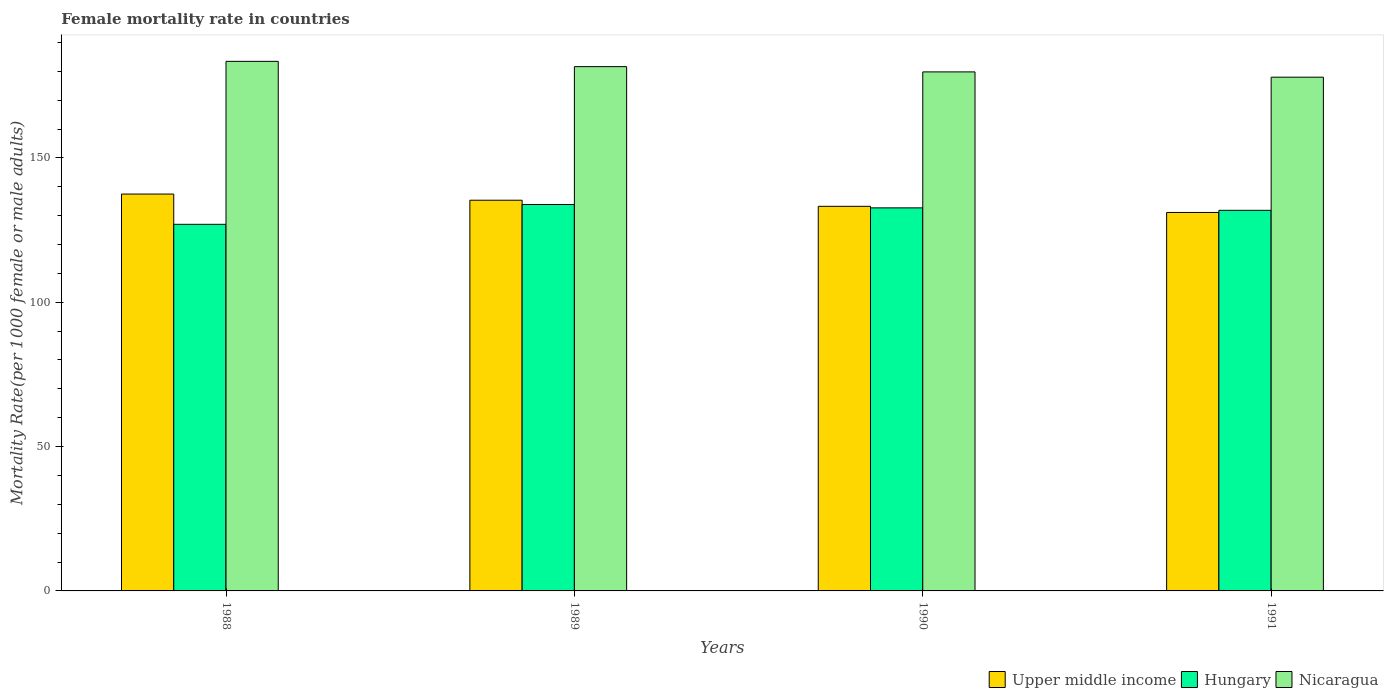How many different coloured bars are there?
Give a very brief answer. 3. How many groups of bars are there?
Offer a very short reply. 4. How many bars are there on the 1st tick from the right?
Ensure brevity in your answer.  3. What is the female mortality rate in Upper middle income in 1988?
Your response must be concise. 137.48. Across all years, what is the maximum female mortality rate in Upper middle income?
Your answer should be very brief. 137.48. Across all years, what is the minimum female mortality rate in Upper middle income?
Ensure brevity in your answer.  131.1. In which year was the female mortality rate in Upper middle income minimum?
Offer a terse response. 1991. What is the total female mortality rate in Upper middle income in the graph?
Your answer should be very brief. 537.16. What is the difference between the female mortality rate in Upper middle income in 1989 and that in 1991?
Offer a very short reply. 4.24. What is the difference between the female mortality rate in Hungary in 1989 and the female mortality rate in Nicaragua in 1991?
Keep it short and to the point. -44.12. What is the average female mortality rate in Upper middle income per year?
Provide a short and direct response. 134.29. In the year 1988, what is the difference between the female mortality rate in Nicaragua and female mortality rate in Hungary?
Offer a very short reply. 56.45. In how many years, is the female mortality rate in Nicaragua greater than 110?
Provide a short and direct response. 4. What is the ratio of the female mortality rate in Upper middle income in 1990 to that in 1991?
Offer a terse response. 1.02. Is the female mortality rate in Hungary in 1989 less than that in 1991?
Provide a succinct answer. No. What is the difference between the highest and the second highest female mortality rate in Hungary?
Make the answer very short. 1.16. What is the difference between the highest and the lowest female mortality rate in Hungary?
Your answer should be compact. 6.86. In how many years, is the female mortality rate in Hungary greater than the average female mortality rate in Hungary taken over all years?
Keep it short and to the point. 3. Is the sum of the female mortality rate in Upper middle income in 1988 and 1990 greater than the maximum female mortality rate in Hungary across all years?
Make the answer very short. Yes. What does the 2nd bar from the left in 1990 represents?
Keep it short and to the point. Hungary. What does the 2nd bar from the right in 1989 represents?
Make the answer very short. Hungary. Is it the case that in every year, the sum of the female mortality rate in Hungary and female mortality rate in Upper middle income is greater than the female mortality rate in Nicaragua?
Provide a short and direct response. Yes. How many years are there in the graph?
Your answer should be compact. 4. What is the difference between two consecutive major ticks on the Y-axis?
Make the answer very short. 50. Are the values on the major ticks of Y-axis written in scientific E-notation?
Keep it short and to the point. No. Does the graph contain grids?
Your answer should be compact. No. Where does the legend appear in the graph?
Ensure brevity in your answer.  Bottom right. How many legend labels are there?
Ensure brevity in your answer.  3. What is the title of the graph?
Your response must be concise. Female mortality rate in countries. Does "Albania" appear as one of the legend labels in the graph?
Offer a very short reply. No. What is the label or title of the Y-axis?
Your answer should be compact. Mortality Rate(per 1000 female or male adults). What is the Mortality Rate(per 1000 female or male adults) of Upper middle income in 1988?
Your answer should be very brief. 137.48. What is the Mortality Rate(per 1000 female or male adults) in Hungary in 1988?
Your answer should be compact. 127. What is the Mortality Rate(per 1000 female or male adults) of Nicaragua in 1988?
Ensure brevity in your answer.  183.45. What is the Mortality Rate(per 1000 female or male adults) of Upper middle income in 1989?
Your answer should be compact. 135.34. What is the Mortality Rate(per 1000 female or male adults) of Hungary in 1989?
Make the answer very short. 133.85. What is the Mortality Rate(per 1000 female or male adults) in Nicaragua in 1989?
Offer a terse response. 181.62. What is the Mortality Rate(per 1000 female or male adults) in Upper middle income in 1990?
Offer a terse response. 133.23. What is the Mortality Rate(per 1000 female or male adults) of Hungary in 1990?
Offer a terse response. 132.69. What is the Mortality Rate(per 1000 female or male adults) of Nicaragua in 1990?
Provide a short and direct response. 179.8. What is the Mortality Rate(per 1000 female or male adults) in Upper middle income in 1991?
Your response must be concise. 131.1. What is the Mortality Rate(per 1000 female or male adults) of Hungary in 1991?
Provide a succinct answer. 131.85. What is the Mortality Rate(per 1000 female or male adults) in Nicaragua in 1991?
Keep it short and to the point. 177.97. Across all years, what is the maximum Mortality Rate(per 1000 female or male adults) in Upper middle income?
Offer a terse response. 137.48. Across all years, what is the maximum Mortality Rate(per 1000 female or male adults) of Hungary?
Give a very brief answer. 133.85. Across all years, what is the maximum Mortality Rate(per 1000 female or male adults) of Nicaragua?
Offer a terse response. 183.45. Across all years, what is the minimum Mortality Rate(per 1000 female or male adults) of Upper middle income?
Your response must be concise. 131.1. Across all years, what is the minimum Mortality Rate(per 1000 female or male adults) in Hungary?
Ensure brevity in your answer.  127. Across all years, what is the minimum Mortality Rate(per 1000 female or male adults) in Nicaragua?
Keep it short and to the point. 177.97. What is the total Mortality Rate(per 1000 female or male adults) of Upper middle income in the graph?
Offer a terse response. 537.16. What is the total Mortality Rate(per 1000 female or male adults) in Hungary in the graph?
Your answer should be very brief. 525.39. What is the total Mortality Rate(per 1000 female or male adults) of Nicaragua in the graph?
Keep it short and to the point. 722.84. What is the difference between the Mortality Rate(per 1000 female or male adults) in Upper middle income in 1988 and that in 1989?
Ensure brevity in your answer.  2.14. What is the difference between the Mortality Rate(per 1000 female or male adults) in Hungary in 1988 and that in 1989?
Provide a short and direct response. -6.86. What is the difference between the Mortality Rate(per 1000 female or male adults) in Nicaragua in 1988 and that in 1989?
Your response must be concise. 1.83. What is the difference between the Mortality Rate(per 1000 female or male adults) in Upper middle income in 1988 and that in 1990?
Keep it short and to the point. 4.25. What is the difference between the Mortality Rate(per 1000 female or male adults) in Hungary in 1988 and that in 1990?
Provide a short and direct response. -5.7. What is the difference between the Mortality Rate(per 1000 female or male adults) in Nicaragua in 1988 and that in 1990?
Provide a short and direct response. 3.65. What is the difference between the Mortality Rate(per 1000 female or male adults) of Upper middle income in 1988 and that in 1991?
Provide a succinct answer. 6.38. What is the difference between the Mortality Rate(per 1000 female or male adults) in Hungary in 1988 and that in 1991?
Make the answer very short. -4.85. What is the difference between the Mortality Rate(per 1000 female or male adults) of Nicaragua in 1988 and that in 1991?
Make the answer very short. 5.48. What is the difference between the Mortality Rate(per 1000 female or male adults) in Upper middle income in 1989 and that in 1990?
Your answer should be compact. 2.11. What is the difference between the Mortality Rate(per 1000 female or male adults) of Hungary in 1989 and that in 1990?
Offer a terse response. 1.16. What is the difference between the Mortality Rate(per 1000 female or male adults) of Nicaragua in 1989 and that in 1990?
Ensure brevity in your answer.  1.83. What is the difference between the Mortality Rate(per 1000 female or male adults) in Upper middle income in 1989 and that in 1991?
Provide a short and direct response. 4.24. What is the difference between the Mortality Rate(per 1000 female or male adults) in Hungary in 1989 and that in 1991?
Ensure brevity in your answer.  2.01. What is the difference between the Mortality Rate(per 1000 female or male adults) of Nicaragua in 1989 and that in 1991?
Offer a terse response. 3.65. What is the difference between the Mortality Rate(per 1000 female or male adults) in Upper middle income in 1990 and that in 1991?
Your response must be concise. 2.13. What is the difference between the Mortality Rate(per 1000 female or male adults) of Hungary in 1990 and that in 1991?
Make the answer very short. 0.85. What is the difference between the Mortality Rate(per 1000 female or male adults) of Nicaragua in 1990 and that in 1991?
Your response must be concise. 1.83. What is the difference between the Mortality Rate(per 1000 female or male adults) of Upper middle income in 1988 and the Mortality Rate(per 1000 female or male adults) of Hungary in 1989?
Offer a very short reply. 3.63. What is the difference between the Mortality Rate(per 1000 female or male adults) in Upper middle income in 1988 and the Mortality Rate(per 1000 female or male adults) in Nicaragua in 1989?
Keep it short and to the point. -44.14. What is the difference between the Mortality Rate(per 1000 female or male adults) in Hungary in 1988 and the Mortality Rate(per 1000 female or male adults) in Nicaragua in 1989?
Make the answer very short. -54.63. What is the difference between the Mortality Rate(per 1000 female or male adults) in Upper middle income in 1988 and the Mortality Rate(per 1000 female or male adults) in Hungary in 1990?
Ensure brevity in your answer.  4.79. What is the difference between the Mortality Rate(per 1000 female or male adults) in Upper middle income in 1988 and the Mortality Rate(per 1000 female or male adults) in Nicaragua in 1990?
Make the answer very short. -42.31. What is the difference between the Mortality Rate(per 1000 female or male adults) of Hungary in 1988 and the Mortality Rate(per 1000 female or male adults) of Nicaragua in 1990?
Provide a short and direct response. -52.8. What is the difference between the Mortality Rate(per 1000 female or male adults) of Upper middle income in 1988 and the Mortality Rate(per 1000 female or male adults) of Hungary in 1991?
Provide a short and direct response. 5.64. What is the difference between the Mortality Rate(per 1000 female or male adults) in Upper middle income in 1988 and the Mortality Rate(per 1000 female or male adults) in Nicaragua in 1991?
Your answer should be very brief. -40.49. What is the difference between the Mortality Rate(per 1000 female or male adults) in Hungary in 1988 and the Mortality Rate(per 1000 female or male adults) in Nicaragua in 1991?
Offer a very short reply. -50.97. What is the difference between the Mortality Rate(per 1000 female or male adults) in Upper middle income in 1989 and the Mortality Rate(per 1000 female or male adults) in Hungary in 1990?
Your response must be concise. 2.64. What is the difference between the Mortality Rate(per 1000 female or male adults) in Upper middle income in 1989 and the Mortality Rate(per 1000 female or male adults) in Nicaragua in 1990?
Give a very brief answer. -44.46. What is the difference between the Mortality Rate(per 1000 female or male adults) of Hungary in 1989 and the Mortality Rate(per 1000 female or male adults) of Nicaragua in 1990?
Make the answer very short. -45.94. What is the difference between the Mortality Rate(per 1000 female or male adults) in Upper middle income in 1989 and the Mortality Rate(per 1000 female or male adults) in Hungary in 1991?
Your answer should be very brief. 3.49. What is the difference between the Mortality Rate(per 1000 female or male adults) of Upper middle income in 1989 and the Mortality Rate(per 1000 female or male adults) of Nicaragua in 1991?
Your response must be concise. -42.63. What is the difference between the Mortality Rate(per 1000 female or male adults) in Hungary in 1989 and the Mortality Rate(per 1000 female or male adults) in Nicaragua in 1991?
Your answer should be compact. -44.12. What is the difference between the Mortality Rate(per 1000 female or male adults) of Upper middle income in 1990 and the Mortality Rate(per 1000 female or male adults) of Hungary in 1991?
Your answer should be compact. 1.39. What is the difference between the Mortality Rate(per 1000 female or male adults) of Upper middle income in 1990 and the Mortality Rate(per 1000 female or male adults) of Nicaragua in 1991?
Your answer should be very brief. -44.74. What is the difference between the Mortality Rate(per 1000 female or male adults) of Hungary in 1990 and the Mortality Rate(per 1000 female or male adults) of Nicaragua in 1991?
Provide a short and direct response. -45.27. What is the average Mortality Rate(per 1000 female or male adults) of Upper middle income per year?
Make the answer very short. 134.29. What is the average Mortality Rate(per 1000 female or male adults) in Hungary per year?
Provide a short and direct response. 131.35. What is the average Mortality Rate(per 1000 female or male adults) of Nicaragua per year?
Give a very brief answer. 180.71. In the year 1988, what is the difference between the Mortality Rate(per 1000 female or male adults) of Upper middle income and Mortality Rate(per 1000 female or male adults) of Hungary?
Provide a short and direct response. 10.49. In the year 1988, what is the difference between the Mortality Rate(per 1000 female or male adults) of Upper middle income and Mortality Rate(per 1000 female or male adults) of Nicaragua?
Your response must be concise. -45.97. In the year 1988, what is the difference between the Mortality Rate(per 1000 female or male adults) in Hungary and Mortality Rate(per 1000 female or male adults) in Nicaragua?
Keep it short and to the point. -56.45. In the year 1989, what is the difference between the Mortality Rate(per 1000 female or male adults) of Upper middle income and Mortality Rate(per 1000 female or male adults) of Hungary?
Make the answer very short. 1.49. In the year 1989, what is the difference between the Mortality Rate(per 1000 female or male adults) in Upper middle income and Mortality Rate(per 1000 female or male adults) in Nicaragua?
Your answer should be compact. -46.28. In the year 1989, what is the difference between the Mortality Rate(per 1000 female or male adults) of Hungary and Mortality Rate(per 1000 female or male adults) of Nicaragua?
Your answer should be compact. -47.77. In the year 1990, what is the difference between the Mortality Rate(per 1000 female or male adults) of Upper middle income and Mortality Rate(per 1000 female or male adults) of Hungary?
Offer a terse response. 0.54. In the year 1990, what is the difference between the Mortality Rate(per 1000 female or male adults) in Upper middle income and Mortality Rate(per 1000 female or male adults) in Nicaragua?
Make the answer very short. -46.56. In the year 1990, what is the difference between the Mortality Rate(per 1000 female or male adults) of Hungary and Mortality Rate(per 1000 female or male adults) of Nicaragua?
Make the answer very short. -47.1. In the year 1991, what is the difference between the Mortality Rate(per 1000 female or male adults) of Upper middle income and Mortality Rate(per 1000 female or male adults) of Hungary?
Provide a short and direct response. -0.74. In the year 1991, what is the difference between the Mortality Rate(per 1000 female or male adults) in Upper middle income and Mortality Rate(per 1000 female or male adults) in Nicaragua?
Make the answer very short. -46.87. In the year 1991, what is the difference between the Mortality Rate(per 1000 female or male adults) in Hungary and Mortality Rate(per 1000 female or male adults) in Nicaragua?
Give a very brief answer. -46.12. What is the ratio of the Mortality Rate(per 1000 female or male adults) in Upper middle income in 1988 to that in 1989?
Your answer should be compact. 1.02. What is the ratio of the Mortality Rate(per 1000 female or male adults) of Hungary in 1988 to that in 1989?
Your answer should be compact. 0.95. What is the ratio of the Mortality Rate(per 1000 female or male adults) in Nicaragua in 1988 to that in 1989?
Make the answer very short. 1.01. What is the ratio of the Mortality Rate(per 1000 female or male adults) in Upper middle income in 1988 to that in 1990?
Keep it short and to the point. 1.03. What is the ratio of the Mortality Rate(per 1000 female or male adults) in Hungary in 1988 to that in 1990?
Offer a very short reply. 0.96. What is the ratio of the Mortality Rate(per 1000 female or male adults) of Nicaragua in 1988 to that in 1990?
Give a very brief answer. 1.02. What is the ratio of the Mortality Rate(per 1000 female or male adults) of Upper middle income in 1988 to that in 1991?
Make the answer very short. 1.05. What is the ratio of the Mortality Rate(per 1000 female or male adults) in Hungary in 1988 to that in 1991?
Offer a very short reply. 0.96. What is the ratio of the Mortality Rate(per 1000 female or male adults) of Nicaragua in 1988 to that in 1991?
Your answer should be compact. 1.03. What is the ratio of the Mortality Rate(per 1000 female or male adults) in Upper middle income in 1989 to that in 1990?
Offer a terse response. 1.02. What is the ratio of the Mortality Rate(per 1000 female or male adults) of Hungary in 1989 to that in 1990?
Keep it short and to the point. 1.01. What is the ratio of the Mortality Rate(per 1000 female or male adults) in Nicaragua in 1989 to that in 1990?
Provide a short and direct response. 1.01. What is the ratio of the Mortality Rate(per 1000 female or male adults) in Upper middle income in 1989 to that in 1991?
Your response must be concise. 1.03. What is the ratio of the Mortality Rate(per 1000 female or male adults) of Hungary in 1989 to that in 1991?
Give a very brief answer. 1.02. What is the ratio of the Mortality Rate(per 1000 female or male adults) of Nicaragua in 1989 to that in 1991?
Offer a very short reply. 1.02. What is the ratio of the Mortality Rate(per 1000 female or male adults) in Upper middle income in 1990 to that in 1991?
Provide a short and direct response. 1.02. What is the ratio of the Mortality Rate(per 1000 female or male adults) in Hungary in 1990 to that in 1991?
Provide a short and direct response. 1.01. What is the ratio of the Mortality Rate(per 1000 female or male adults) of Nicaragua in 1990 to that in 1991?
Provide a succinct answer. 1.01. What is the difference between the highest and the second highest Mortality Rate(per 1000 female or male adults) in Upper middle income?
Your response must be concise. 2.14. What is the difference between the highest and the second highest Mortality Rate(per 1000 female or male adults) of Hungary?
Offer a very short reply. 1.16. What is the difference between the highest and the second highest Mortality Rate(per 1000 female or male adults) of Nicaragua?
Your answer should be very brief. 1.83. What is the difference between the highest and the lowest Mortality Rate(per 1000 female or male adults) in Upper middle income?
Your answer should be very brief. 6.38. What is the difference between the highest and the lowest Mortality Rate(per 1000 female or male adults) in Hungary?
Your answer should be compact. 6.86. What is the difference between the highest and the lowest Mortality Rate(per 1000 female or male adults) of Nicaragua?
Provide a short and direct response. 5.48. 